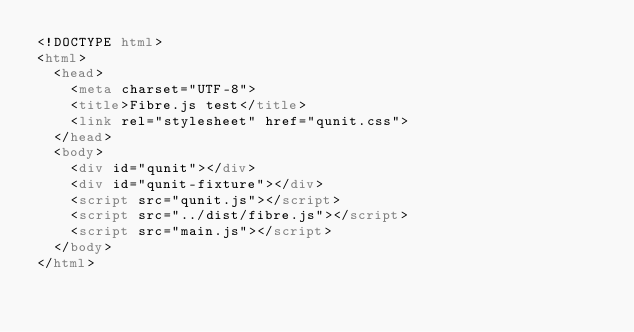Convert code to text. <code><loc_0><loc_0><loc_500><loc_500><_HTML_><!DOCTYPE html>
<html>
  <head>
    <meta charset="UTF-8">
    <title>Fibre.js test</title>
    <link rel="stylesheet" href="qunit.css">
  </head>
  <body>
    <div id="qunit"></div>
    <div id="qunit-fixture"></div>
    <script src="qunit.js"></script>
    <script src="../dist/fibre.js"></script>
    <script src="main.js"></script>
  </body>
</html></code> 